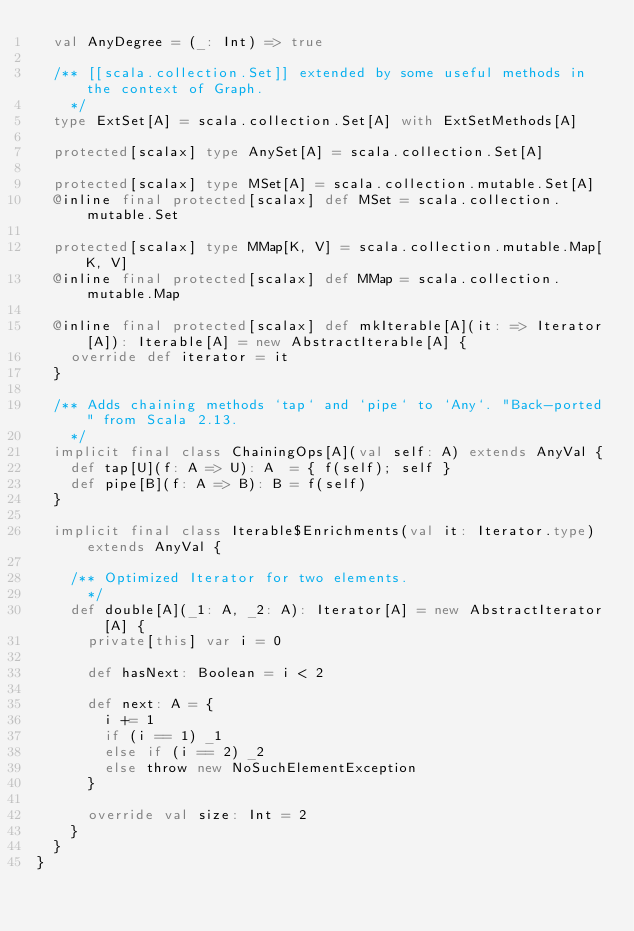<code> <loc_0><loc_0><loc_500><loc_500><_Scala_>  val AnyDegree = (_: Int) => true

  /** [[scala.collection.Set]] extended by some useful methods in the context of Graph.
    */
  type ExtSet[A] = scala.collection.Set[A] with ExtSetMethods[A]

  protected[scalax] type AnySet[A] = scala.collection.Set[A]

  protected[scalax] type MSet[A] = scala.collection.mutable.Set[A]
  @inline final protected[scalax] def MSet = scala.collection.mutable.Set

  protected[scalax] type MMap[K, V] = scala.collection.mutable.Map[K, V]
  @inline final protected[scalax] def MMap = scala.collection.mutable.Map

  @inline final protected[scalax] def mkIterable[A](it: => Iterator[A]): Iterable[A] = new AbstractIterable[A] {
    override def iterator = it
  }

  /** Adds chaining methods `tap` and `pipe` to `Any`. "Back-ported" from Scala 2.13.
    */
  implicit final class ChainingOps[A](val self: A) extends AnyVal {
    def tap[U](f: A => U): A  = { f(self); self }
    def pipe[B](f: A => B): B = f(self)
  }

  implicit final class Iterable$Enrichments(val it: Iterator.type) extends AnyVal {

    /** Optimized Iterator for two elements.
      */
    def double[A](_1: A, _2: A): Iterator[A] = new AbstractIterator[A] {
      private[this] var i = 0

      def hasNext: Boolean = i < 2

      def next: A = {
        i += 1
        if (i == 1) _1
        else if (i == 2) _2
        else throw new NoSuchElementException
      }

      override val size: Int = 2
    }
  }
}
</code> 